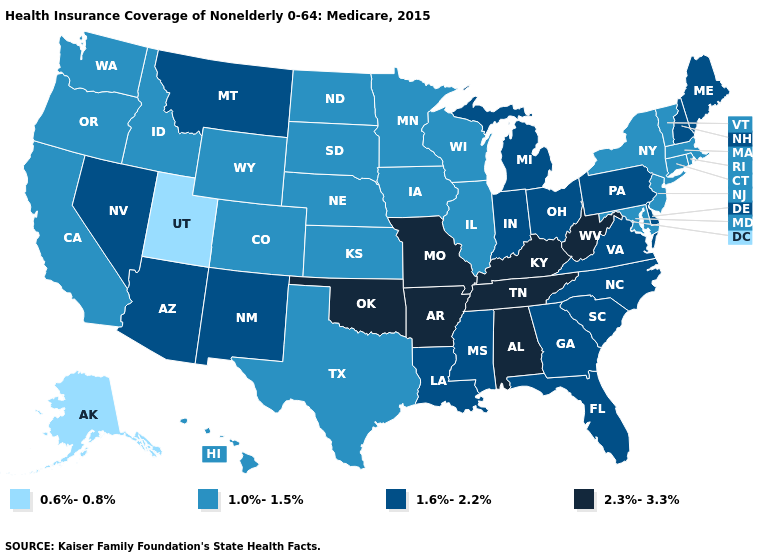Among the states that border Wyoming , does Montana have the highest value?
Concise answer only. Yes. Name the states that have a value in the range 2.3%-3.3%?
Short answer required. Alabama, Arkansas, Kentucky, Missouri, Oklahoma, Tennessee, West Virginia. Does the first symbol in the legend represent the smallest category?
Give a very brief answer. Yes. Does Colorado have the highest value in the USA?
Give a very brief answer. No. Name the states that have a value in the range 1.0%-1.5%?
Short answer required. California, Colorado, Connecticut, Hawaii, Idaho, Illinois, Iowa, Kansas, Maryland, Massachusetts, Minnesota, Nebraska, New Jersey, New York, North Dakota, Oregon, Rhode Island, South Dakota, Texas, Vermont, Washington, Wisconsin, Wyoming. Which states hav the highest value in the MidWest?
Answer briefly. Missouri. What is the highest value in states that border Texas?
Answer briefly. 2.3%-3.3%. Which states have the highest value in the USA?
Concise answer only. Alabama, Arkansas, Kentucky, Missouri, Oklahoma, Tennessee, West Virginia. Among the states that border Pennsylvania , does West Virginia have the highest value?
Short answer required. Yes. Does Colorado have the lowest value in the West?
Quick response, please. No. Does Arizona have the highest value in the West?
Keep it brief. Yes. Does the first symbol in the legend represent the smallest category?
Keep it brief. Yes. Does Mississippi have a higher value than Montana?
Quick response, please. No. Does California have the same value as Michigan?
Write a very short answer. No. What is the value of Michigan?
Short answer required. 1.6%-2.2%. 